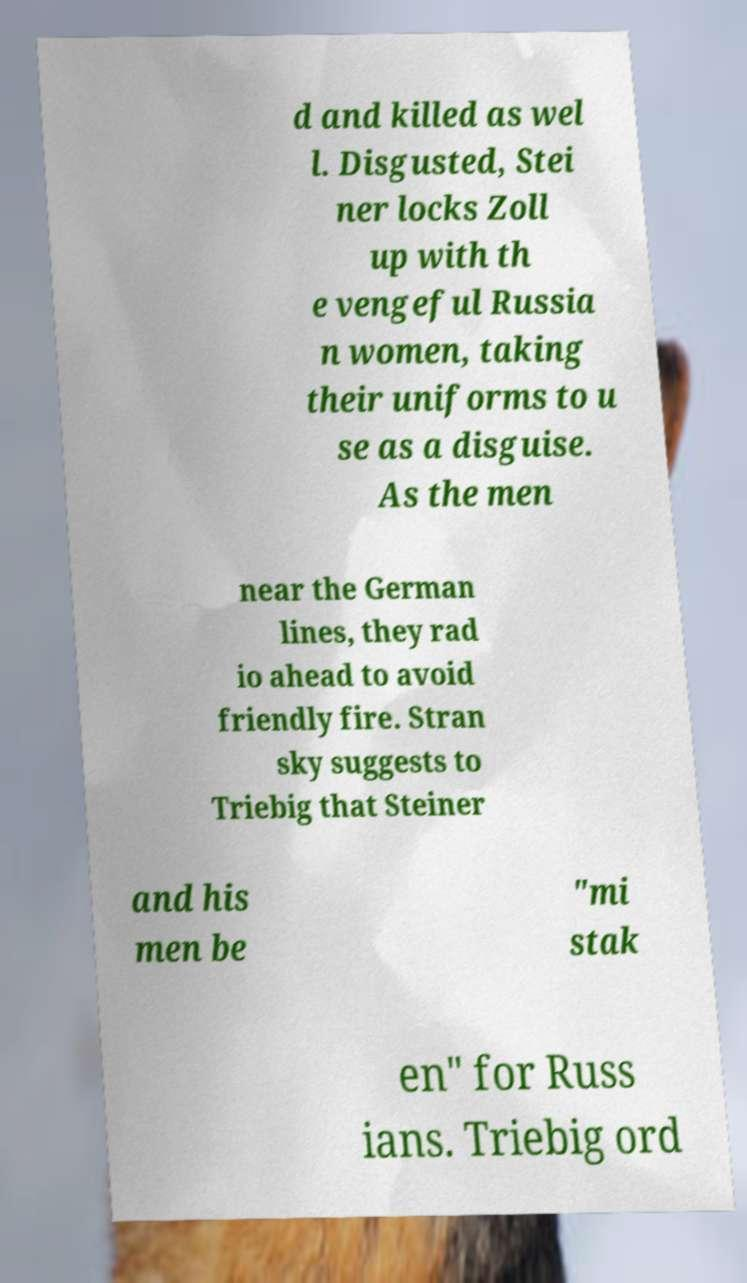Can you read and provide the text displayed in the image?This photo seems to have some interesting text. Can you extract and type it out for me? d and killed as wel l. Disgusted, Stei ner locks Zoll up with th e vengeful Russia n women, taking their uniforms to u se as a disguise. As the men near the German lines, they rad io ahead to avoid friendly fire. Stran sky suggests to Triebig that Steiner and his men be "mi stak en" for Russ ians. Triebig ord 